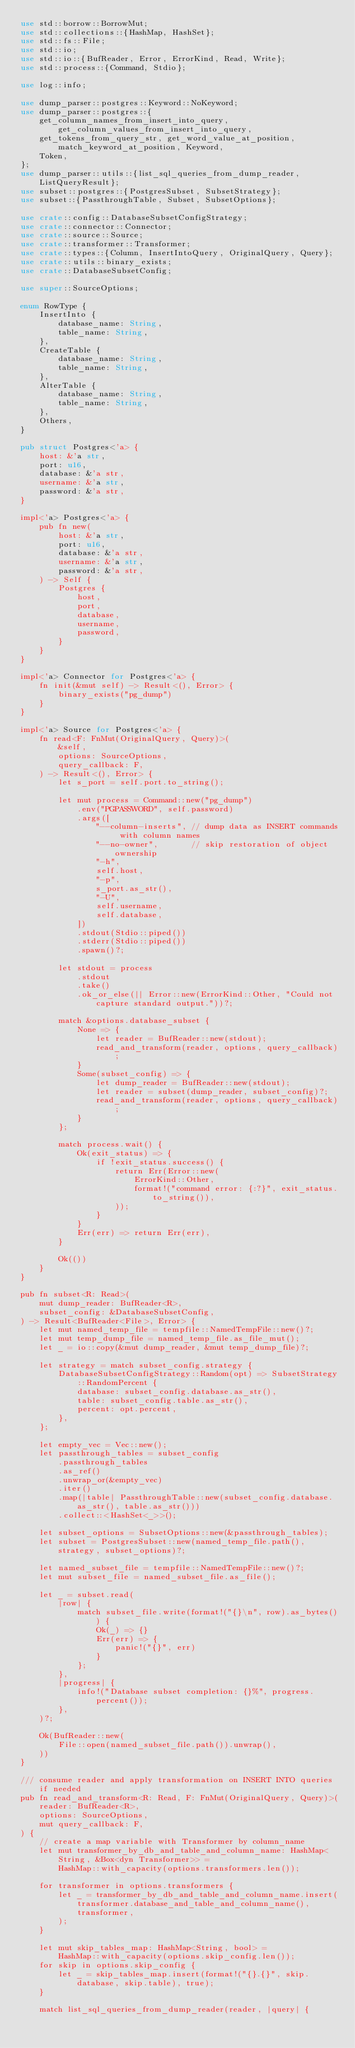<code> <loc_0><loc_0><loc_500><loc_500><_Rust_>use std::borrow::BorrowMut;
use std::collections::{HashMap, HashSet};
use std::fs::File;
use std::io;
use std::io::{BufReader, Error, ErrorKind, Read, Write};
use std::process::{Command, Stdio};

use log::info;

use dump_parser::postgres::Keyword::NoKeyword;
use dump_parser::postgres::{
    get_column_names_from_insert_into_query, get_column_values_from_insert_into_query,
    get_tokens_from_query_str, get_word_value_at_position, match_keyword_at_position, Keyword,
    Token,
};
use dump_parser::utils::{list_sql_queries_from_dump_reader, ListQueryResult};
use subset::postgres::{PostgresSubset, SubsetStrategy};
use subset::{PassthroughTable, Subset, SubsetOptions};

use crate::config::DatabaseSubsetConfigStrategy;
use crate::connector::Connector;
use crate::source::Source;
use crate::transformer::Transformer;
use crate::types::{Column, InsertIntoQuery, OriginalQuery, Query};
use crate::utils::binary_exists;
use crate::DatabaseSubsetConfig;

use super::SourceOptions;

enum RowType {
    InsertInto {
        database_name: String,
        table_name: String,
    },
    CreateTable {
        database_name: String,
        table_name: String,
    },
    AlterTable {
        database_name: String,
        table_name: String,
    },
    Others,
}

pub struct Postgres<'a> {
    host: &'a str,
    port: u16,
    database: &'a str,
    username: &'a str,
    password: &'a str,
}

impl<'a> Postgres<'a> {
    pub fn new(
        host: &'a str,
        port: u16,
        database: &'a str,
        username: &'a str,
        password: &'a str,
    ) -> Self {
        Postgres {
            host,
            port,
            database,
            username,
            password,
        }
    }
}

impl<'a> Connector for Postgres<'a> {
    fn init(&mut self) -> Result<(), Error> {
        binary_exists("pg_dump")
    }
}

impl<'a> Source for Postgres<'a> {
    fn read<F: FnMut(OriginalQuery, Query)>(
        &self,
        options: SourceOptions,
        query_callback: F,
    ) -> Result<(), Error> {
        let s_port = self.port.to_string();

        let mut process = Command::new("pg_dump")
            .env("PGPASSWORD", self.password)
            .args([
                "--column-inserts", // dump data as INSERT commands with column names
                "--no-owner",       // skip restoration of object ownership
                "-h",
                self.host,
                "-p",
                s_port.as_str(),
                "-U",
                self.username,
                self.database,
            ])
            .stdout(Stdio::piped())
            .stderr(Stdio::piped())
            .spawn()?;

        let stdout = process
            .stdout
            .take()
            .ok_or_else(|| Error::new(ErrorKind::Other, "Could not capture standard output."))?;

        match &options.database_subset {
            None => {
                let reader = BufReader::new(stdout);
                read_and_transform(reader, options, query_callback);
            }
            Some(subset_config) => {
                let dump_reader = BufReader::new(stdout);
                let reader = subset(dump_reader, subset_config)?;
                read_and_transform(reader, options, query_callback);
            }
        };

        match process.wait() {
            Ok(exit_status) => {
                if !exit_status.success() {
                    return Err(Error::new(
                        ErrorKind::Other,
                        format!("command error: {:?}", exit_status.to_string()),
                    ));
                }
            }
            Err(err) => return Err(err),
        }

        Ok(())
    }
}

pub fn subset<R: Read>(
    mut dump_reader: BufReader<R>,
    subset_config: &DatabaseSubsetConfig,
) -> Result<BufReader<File>, Error> {
    let mut named_temp_file = tempfile::NamedTempFile::new()?;
    let mut temp_dump_file = named_temp_file.as_file_mut();
    let _ = io::copy(&mut dump_reader, &mut temp_dump_file)?;

    let strategy = match subset_config.strategy {
        DatabaseSubsetConfigStrategy::Random(opt) => SubsetStrategy::RandomPercent {
            database: subset_config.database.as_str(),
            table: subset_config.table.as_str(),
            percent: opt.percent,
        },
    };

    let empty_vec = Vec::new();
    let passthrough_tables = subset_config
        .passthrough_tables
        .as_ref()
        .unwrap_or(&empty_vec)
        .iter()
        .map(|table| PassthroughTable::new(subset_config.database.as_str(), table.as_str()))
        .collect::<HashSet<_>>();

    let subset_options = SubsetOptions::new(&passthrough_tables);
    let subset = PostgresSubset::new(named_temp_file.path(), strategy, subset_options)?;

    let named_subset_file = tempfile::NamedTempFile::new()?;
    let mut subset_file = named_subset_file.as_file();

    let _ = subset.read(
        |row| {
            match subset_file.write(format!("{}\n", row).as_bytes()) {
                Ok(_) => {}
                Err(err) => {
                    panic!("{}", err)
                }
            };
        },
        |progress| {
            info!("Database subset completion: {}%", progress.percent());
        },
    )?;

    Ok(BufReader::new(
        File::open(named_subset_file.path()).unwrap(),
    ))
}

/// consume reader and apply transformation on INSERT INTO queries if needed
pub fn read_and_transform<R: Read, F: FnMut(OriginalQuery, Query)>(
    reader: BufReader<R>,
    options: SourceOptions,
    mut query_callback: F,
) {
    // create a map variable with Transformer by column_name
    let mut transformer_by_db_and_table_and_column_name: HashMap<String, &Box<dyn Transformer>> =
        HashMap::with_capacity(options.transformers.len());

    for transformer in options.transformers {
        let _ = transformer_by_db_and_table_and_column_name.insert(
            transformer.database_and_table_and_column_name(),
            transformer,
        );
    }

    let mut skip_tables_map: HashMap<String, bool> =
        HashMap::with_capacity(options.skip_config.len());
    for skip in options.skip_config {
        let _ = skip_tables_map.insert(format!("{}.{}", skip.database, skip.table), true);
    }

    match list_sql_queries_from_dump_reader(reader, |query| {</code> 